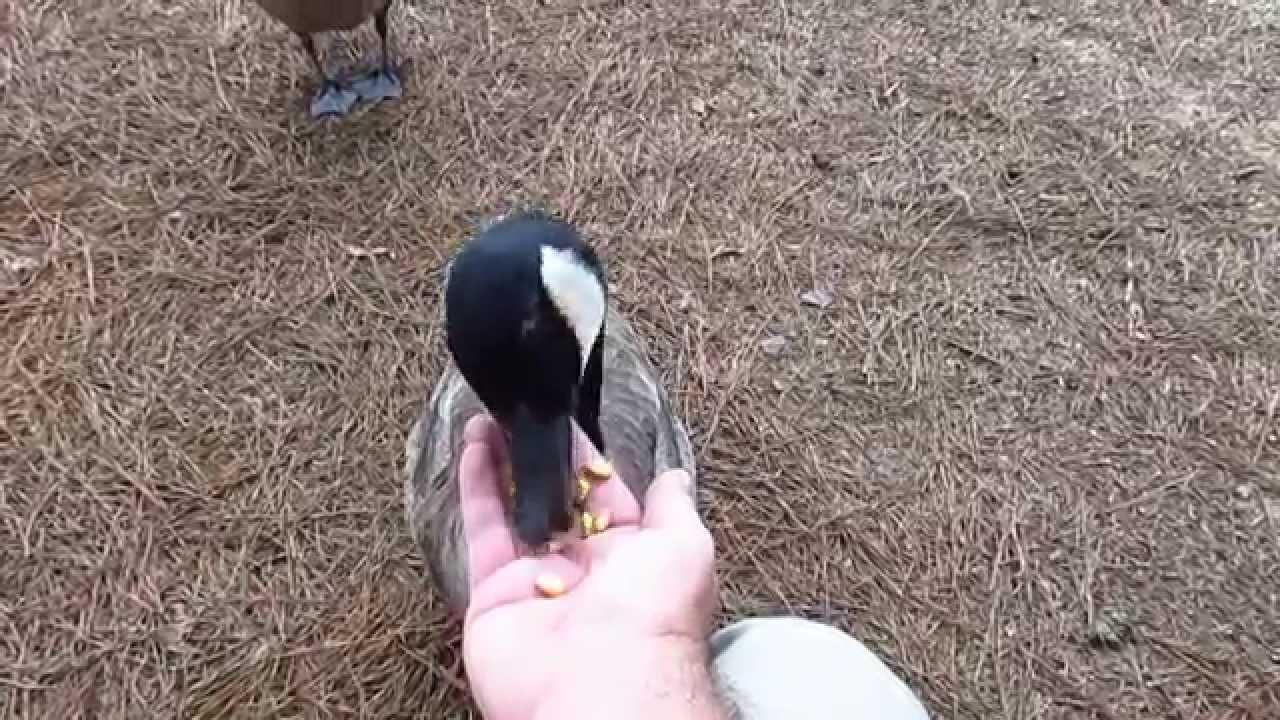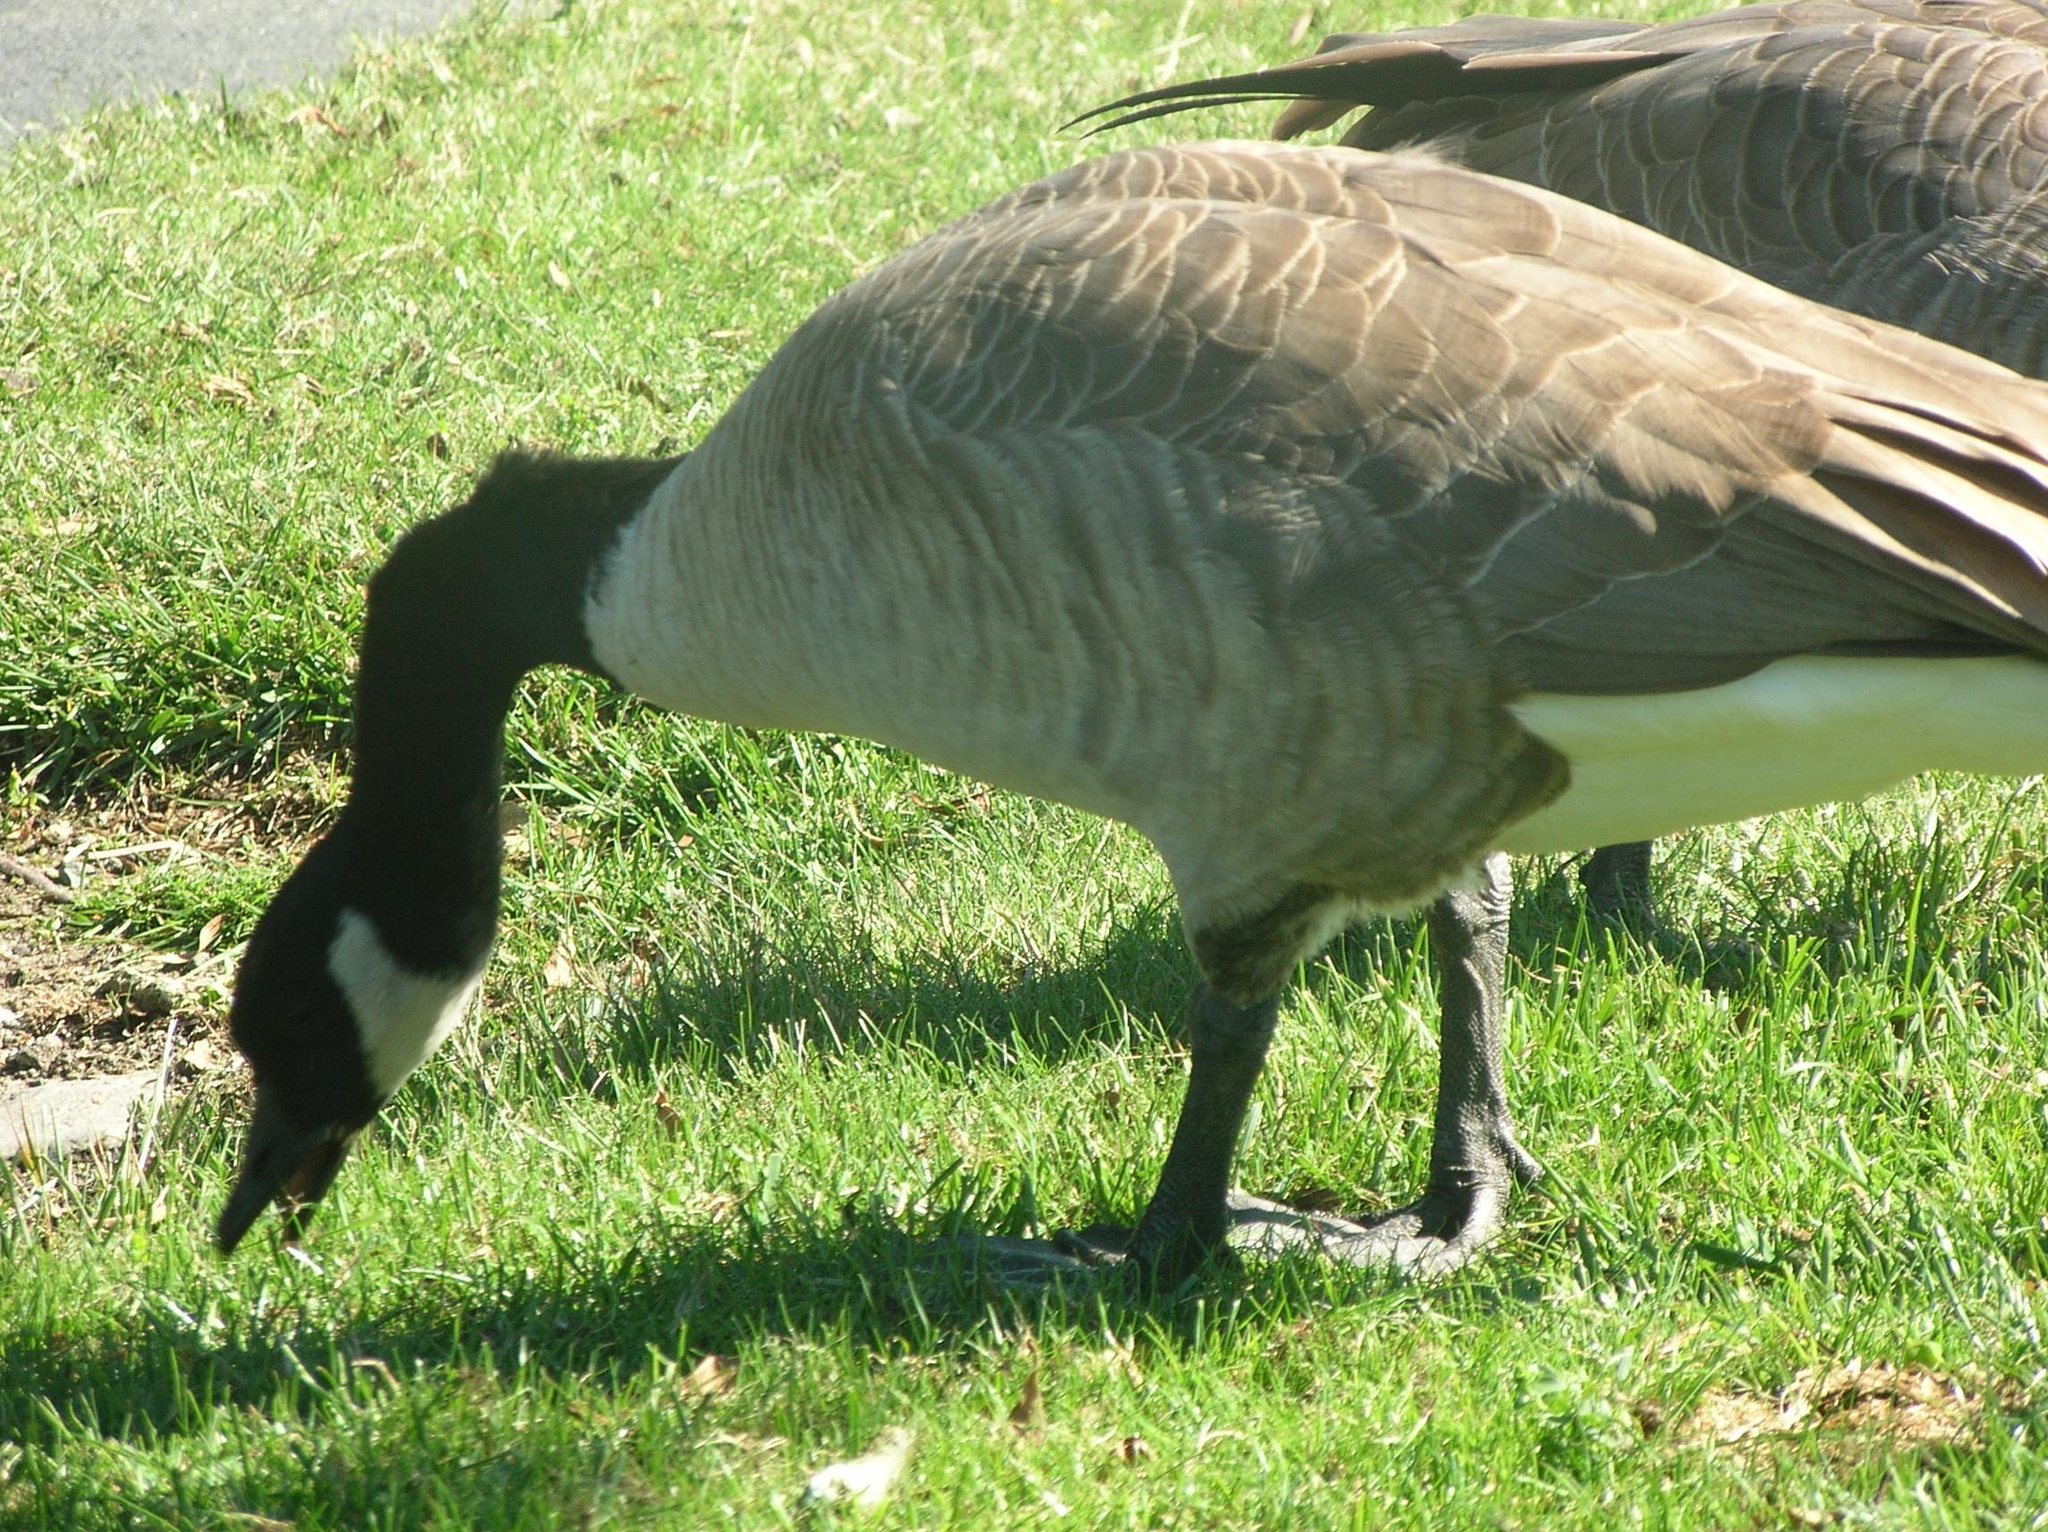The first image is the image on the left, the second image is the image on the right. Evaluate the accuracy of this statement regarding the images: "A girl with long blonde hair is seated beside birds in one of the images.". Is it true? Answer yes or no. No. The first image is the image on the left, the second image is the image on the right. For the images displayed, is the sentence "The left image has at least 4 birds facing left." factually correct? Answer yes or no. No. 